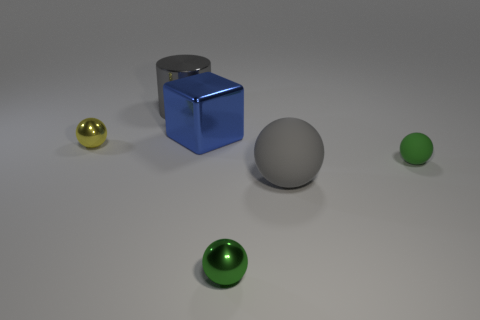What material is the cylinder that is the same color as the big matte sphere?
Your answer should be compact. Metal. What is the size of the object that is both left of the blue object and in front of the shiny cylinder?
Provide a succinct answer. Small. What number of other objects are the same material as the big cylinder?
Keep it short and to the point. 3. There is a green object that is left of the small rubber object; what size is it?
Offer a very short reply. Small. Is the big metal cylinder the same color as the tiny matte ball?
Ensure brevity in your answer.  No. How many small objects are metallic blocks or green metallic balls?
Give a very brief answer. 1. Is there anything else that is the same color as the large cube?
Make the answer very short. No. Are there any things behind the blue thing?
Ensure brevity in your answer.  Yes. There is a green ball that is on the right side of the small metallic thing that is on the right side of the small yellow shiny ball; what size is it?
Keep it short and to the point. Small. Are there an equal number of large shiny objects in front of the big blue metal block and tiny objects that are behind the large gray matte thing?
Offer a very short reply. No. 